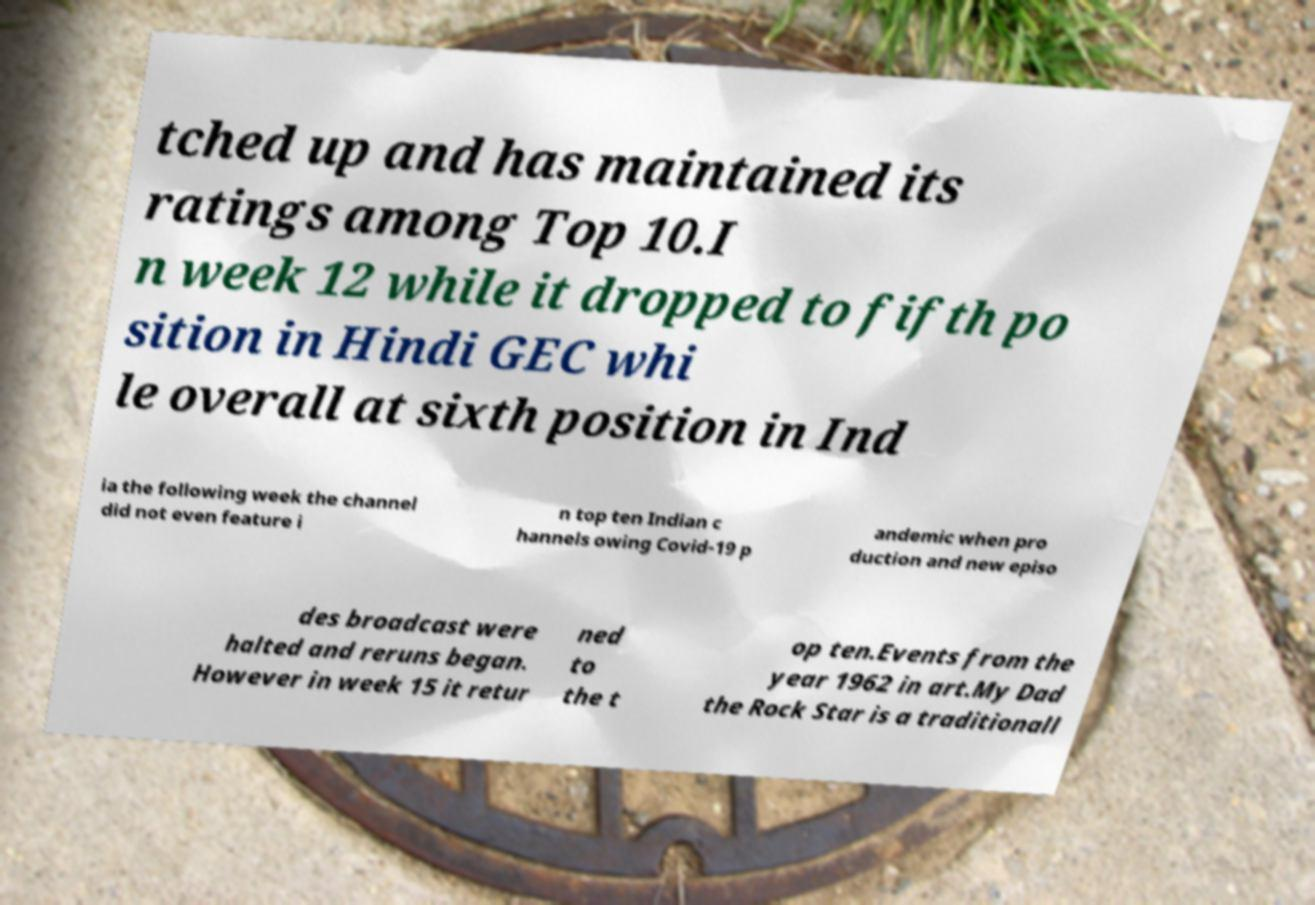There's text embedded in this image that I need extracted. Can you transcribe it verbatim? tched up and has maintained its ratings among Top 10.I n week 12 while it dropped to fifth po sition in Hindi GEC whi le overall at sixth position in Ind ia the following week the channel did not even feature i n top ten Indian c hannels owing Covid-19 p andemic when pro duction and new episo des broadcast were halted and reruns began. However in week 15 it retur ned to the t op ten.Events from the year 1962 in art.My Dad the Rock Star is a traditionall 